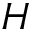<formula> <loc_0><loc_0><loc_500><loc_500>H</formula> 